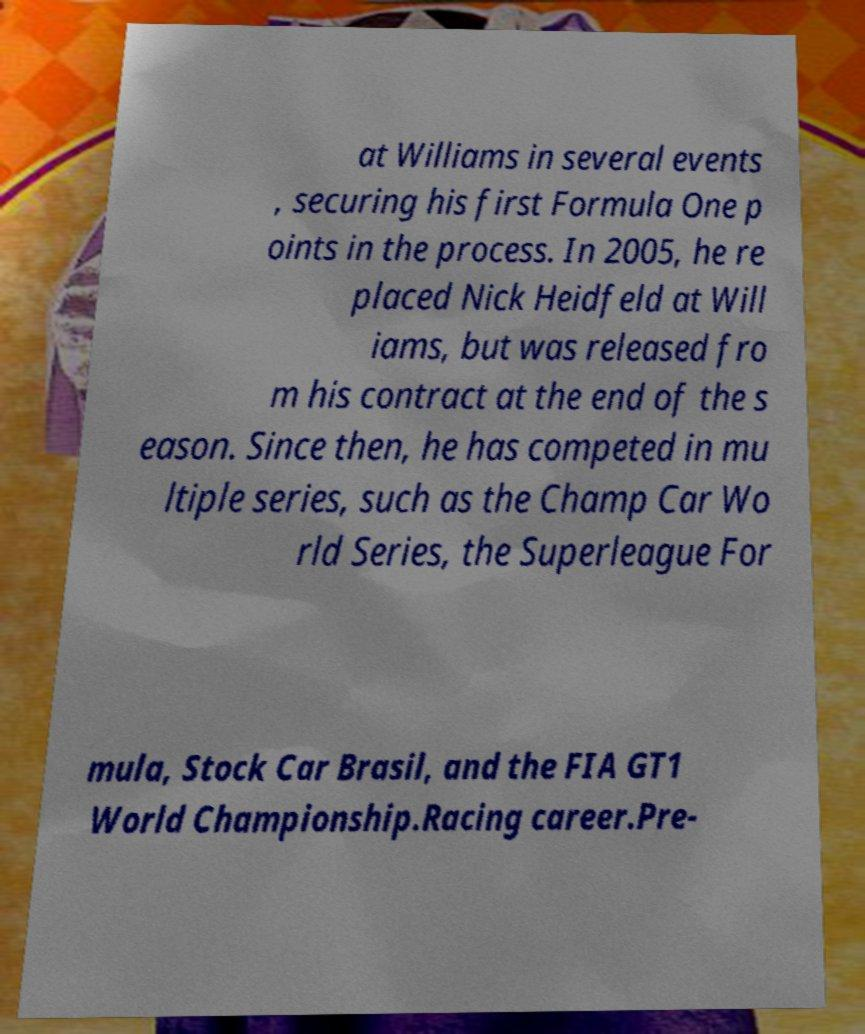Please read and relay the text visible in this image. What does it say? at Williams in several events , securing his first Formula One p oints in the process. In 2005, he re placed Nick Heidfeld at Will iams, but was released fro m his contract at the end of the s eason. Since then, he has competed in mu ltiple series, such as the Champ Car Wo rld Series, the Superleague For mula, Stock Car Brasil, and the FIA GT1 World Championship.Racing career.Pre- 